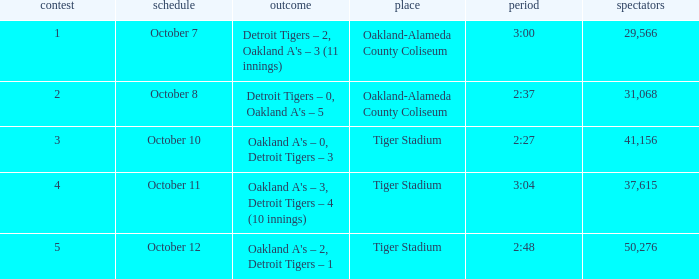What is the number of people in attendance at Oakland-Alameda County Coliseum, and game is 2? 31068.0. 